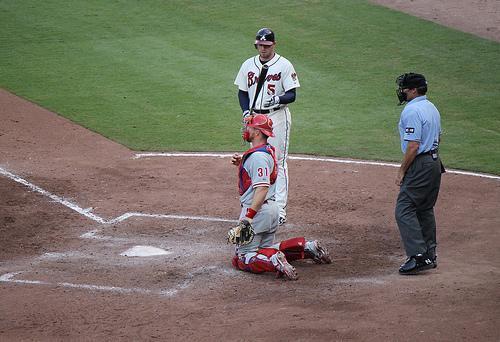How many people in the image wear a blue t-shirt in the picture?
Give a very brief answer. 1. 